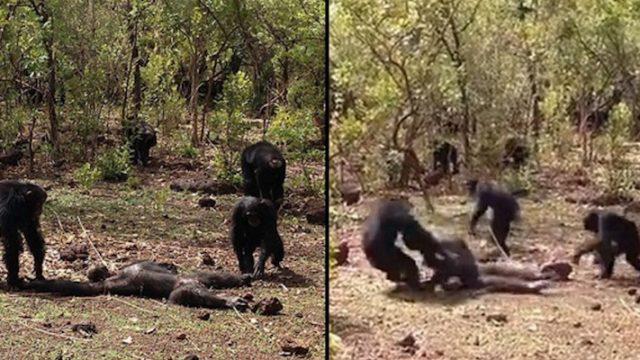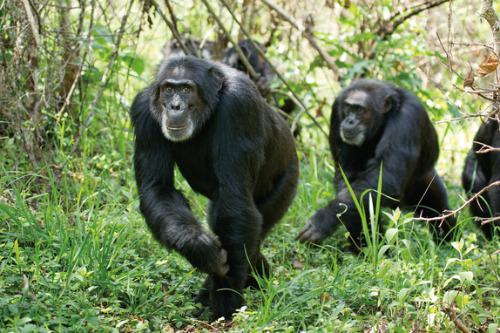The first image is the image on the left, the second image is the image on the right. Assess this claim about the two images: "In one of the image there are 3 chimpanzees on a branch.". Correct or not? Answer yes or no. No. The first image is the image on the left, the second image is the image on the right. Evaluate the accuracy of this statement regarding the images: "The image on the left contains three chimpanzees.". Is it true? Answer yes or no. No. 